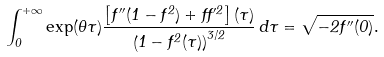Convert formula to latex. <formula><loc_0><loc_0><loc_500><loc_500>\int _ { 0 } ^ { + \infty } \exp ( \theta \tau ) \frac { \left [ f ^ { \prime \prime } ( 1 - f ^ { 2 } ) + f f ^ { \prime 2 } \right ] ( \tau ) } { \left ( 1 - f ^ { 2 } ( \tau ) \right ) ^ { 3 / 2 } } \, d \tau = \sqrt { - 2 f ^ { \prime \prime } ( 0 ) } .</formula> 